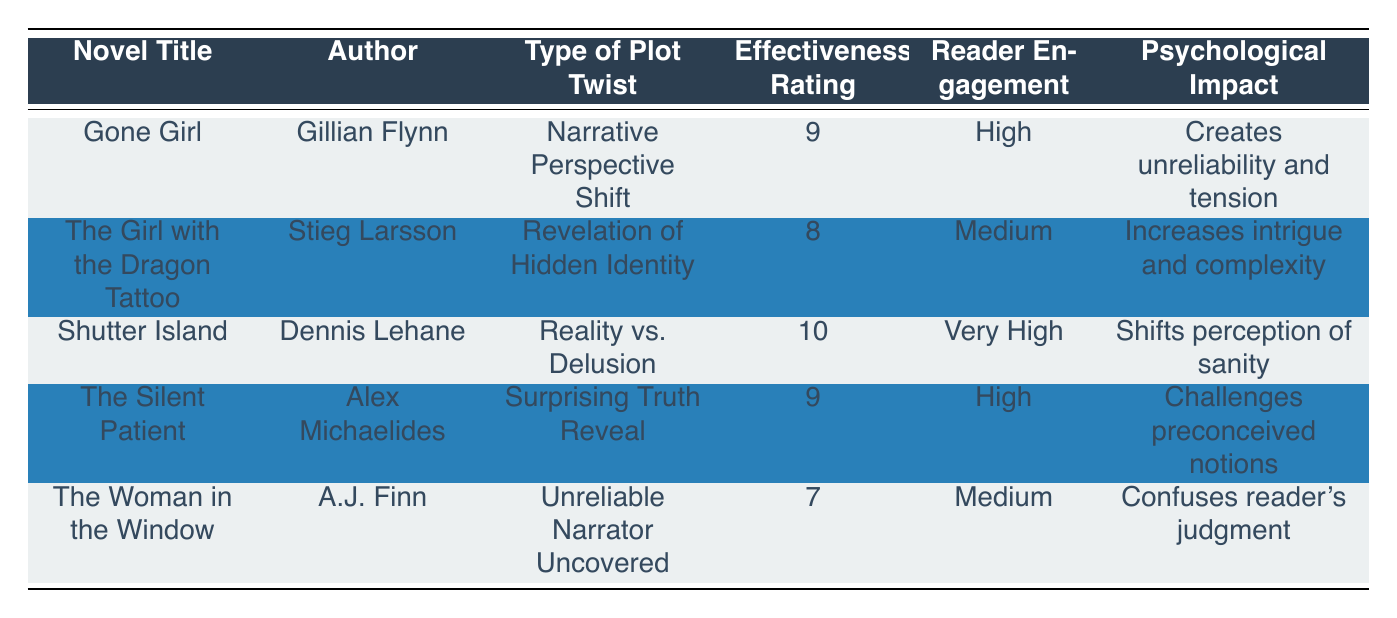What is the effectiveness rating of 'The Silent Patient'? The effectiveness rating for 'The Silent Patient' is listed in the table under the corresponding column. It shows a rating of 9.
Answer: 9 Which novel has the highest effectiveness rating? Looking across the effectiveness ratings in the table, 'Shutter Island' has the highest rating of 10 compared to the others.
Answer: Shutter Island Do any novels have a medium reader engagement level? The reader engagement levels are noted for each novel; 'The Girl with the Dragon Tattoo', 'The Woman in the Window' both have medium engagement levels, confirming there are novels with this rating.
Answer: Yes Which type of plot twist does 'Gone Girl' utilize? Referring to the table, 'Gone Girl' employs the plot twist type called 'Narrative Perspective Shift'.
Answer: Narrative Perspective Shift What psychological impact is associated with 'Shutter Island'? The table indicates that 'Shutter Island's psychological impact is 'Shifts perception of sanity'. This is provided under the psychological impact column.
Answer: Shifts perception of sanity What is the average effectiveness rating of the novels listed? To find the average, first sum the effectiveness ratings (9 + 8 + 10 + 9 + 7 = 43), then divide by the number of novels (5). Thus, the average is 43 / 5 = 8.6.
Answer: 8.6 Is 'The Woman in the Window' rated higher than 'The Girl with the Dragon Tattoo' in terms of effectiveness? Comparing the effectiveness ratings in the table, 'The Woman in the Window' has a rating of 7, while 'The Girl with the Dragon Tattoo' has a rating of 8. Since 7 is not greater than 8, the statement is false.
Answer: No Which novel's plot twist increases intrigue and complexity? Referring to the psychological impact column, 'The Girl with the Dragon Tattoo' states that its twist increases intrigue and complexity.
Answer: The Girl with the Dragon Tattoo Does any novel listed create unreliability and tension? By examining the psychological impact for each novel, the table shows that 'Gone Girl' creates unreliability and tension, confirming the fact.
Answer: Yes 